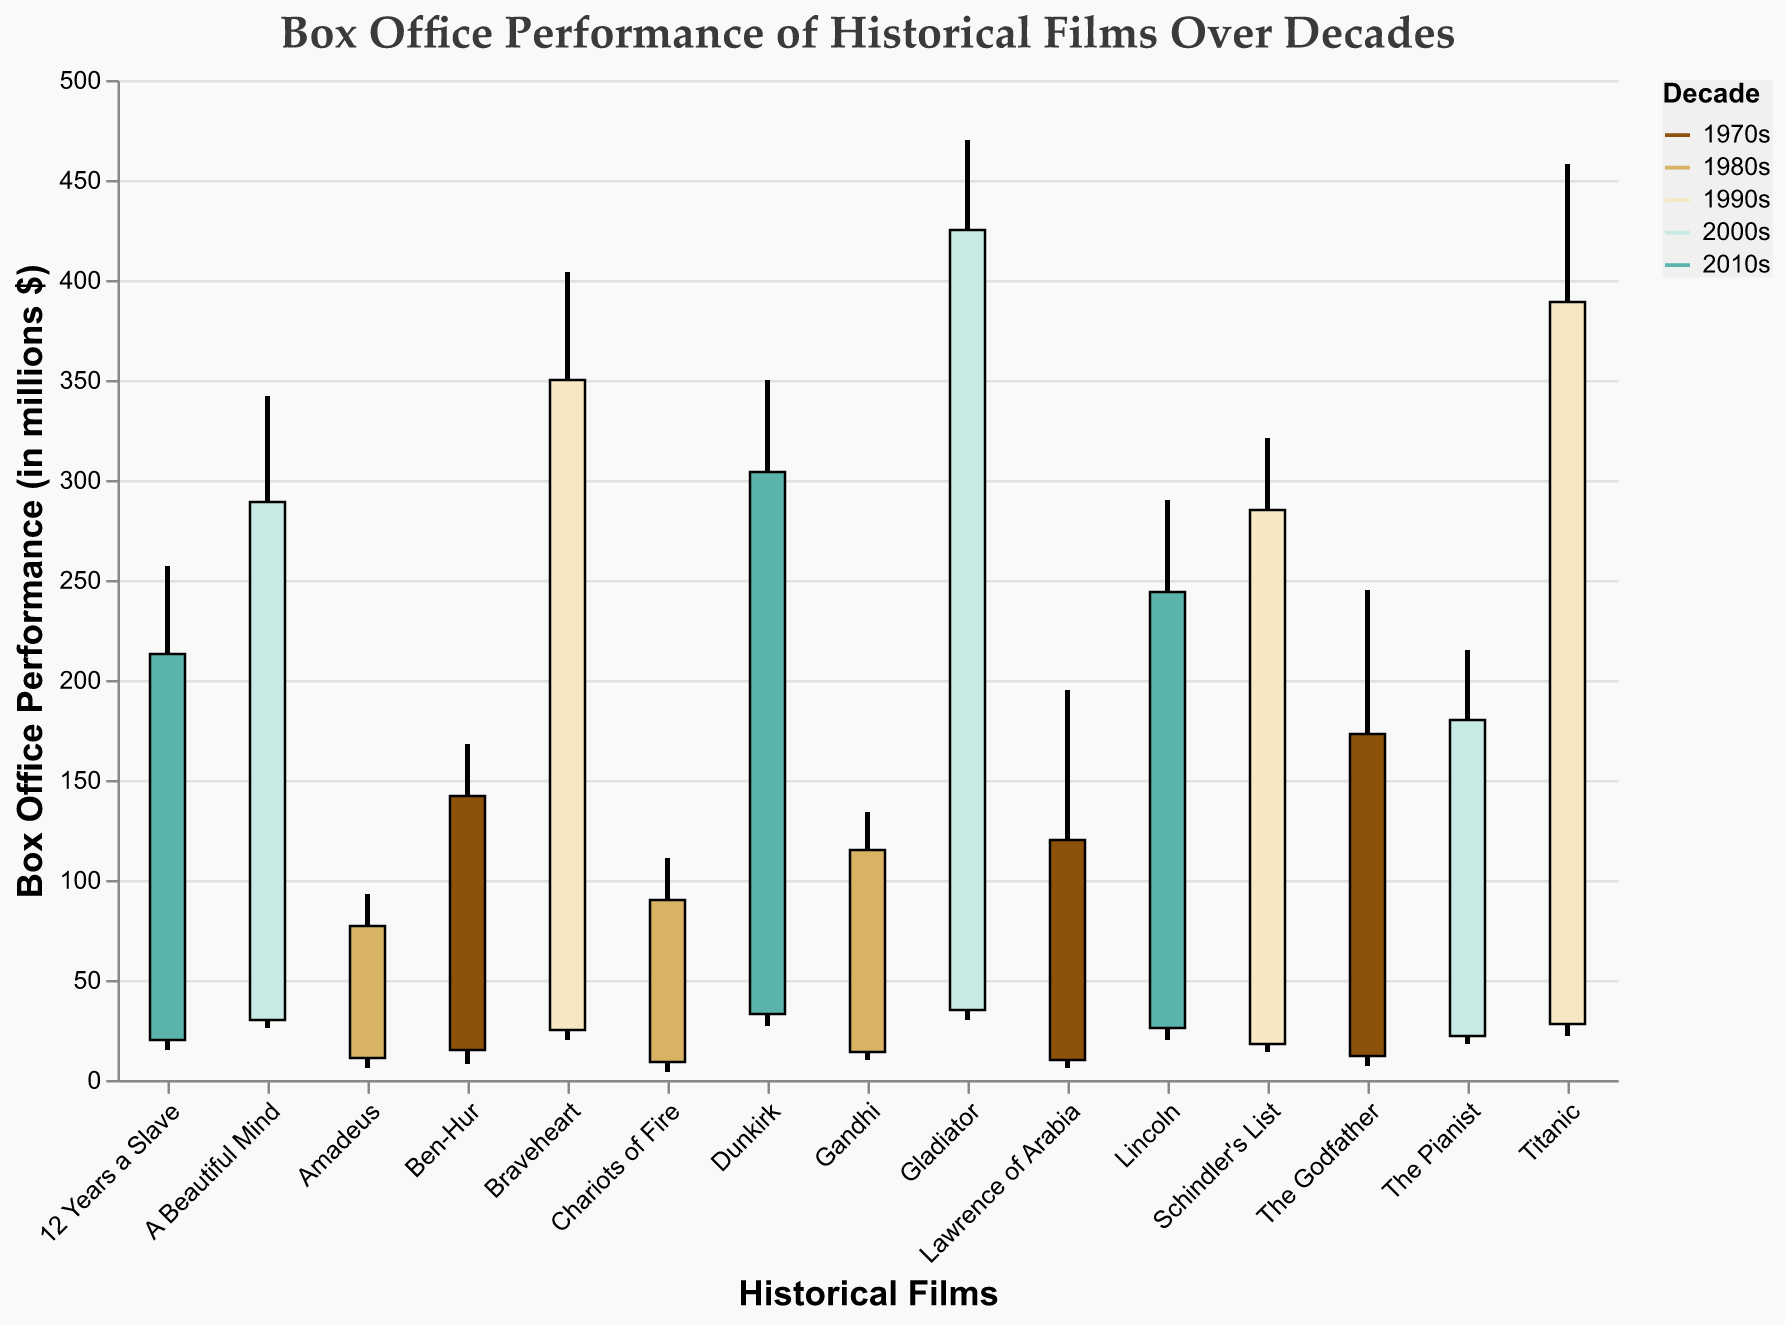What is the highest box office performance value for films of the 1990s? Look for films in the 1990s and identify the "High" values. The highest among them is for Titanic, which is 458.
Answer: 458 What are the box office open and close values for "Schindler's List"? Locate "Schindler's List" and check the "Open" and "Close" fields. "Open" is 18 and "Close" is 285.
Answer: 18 and 285 Which decade has the most films listed in the plot? Count the number of films for each decade. The 2010s have three films listed.
Answer: 2010s What is the range of box office performance (High - Low) for "Gladiator"? Find "Gladiator" and subtract the "Low" value from the "High" value. The range is 470 - 30 = 440.
Answer: 440 Compare the high values of "The Godfather" and "Braveheart". Which one is higher and by how much? Identify the "High" values: "The Godfather" is 245 and "Braveheart" is 404. Calculate the difference: 404 - 245 = 159, so "Braveheart" is higher by 159.
Answer: Braveheart by 159 Which film has the smallest opening value among all films listed? Compare all "Open" values and find the smallest one: "Chariots of Fire" with an "Open" value of 9.
Answer: Chariots of Fire Which film from the 2000s has the highest closing box office performance? Look at the "Close" values for films in the 2000s and find the highest: "Gladiator" has a close value of 425.
Answer: Gladiator What is the average box office performance of the highest values of films in the 1980s? Sum the "High" values for the 1980s: 111 (Chariots of Fire) + 134 (Gandhi) + 93 (Amadeus) = 338. Divide by the number of films: 338 / 3 = 112.67.
Answer: 112.67 Which film in the 2010s has the smallest range between its box office high and low values? Calculate the range (High - Low) for each film in the 2010s and find the smallest: "Lincoln" has a range of 290 - 20 = 244, "12 Years a Slave" has 257 - 15 = 242, and "Dunkirk" has 350 - 27 = 323. The smallest is "12 Years a Slave" with 242.
Answer: 12 Years a Slave 